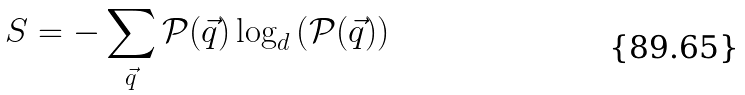Convert formula to latex. <formula><loc_0><loc_0><loc_500><loc_500>S = - \sum _ { \vec { q } } \mathcal { P } ( \vec { q } ) \log _ { d } \left ( \mathcal { P } ( \vec { q } ) \right )</formula> 